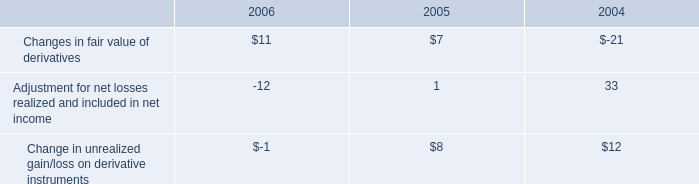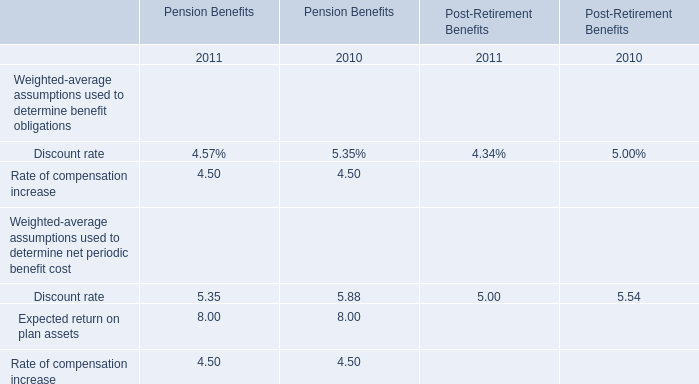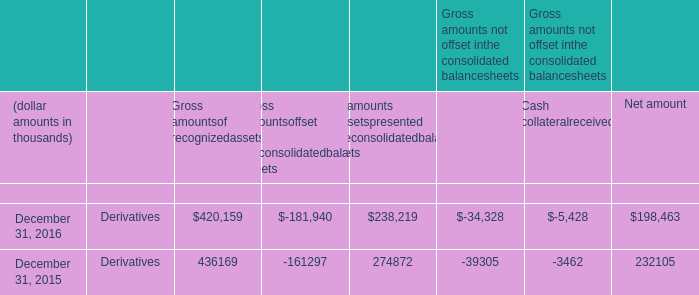what was the total dollar amount of new stock options issues to employees on october 22 , 2003? 
Computations: (13394736 * 11.38)
Answer: 152432095.68. 